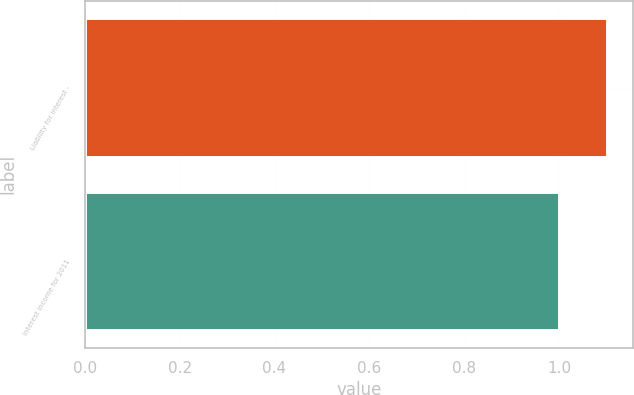Convert chart. <chart><loc_0><loc_0><loc_500><loc_500><bar_chart><fcel>Liability for interest -<fcel>Interest income for 2011<nl><fcel>1.1<fcel>1<nl></chart> 